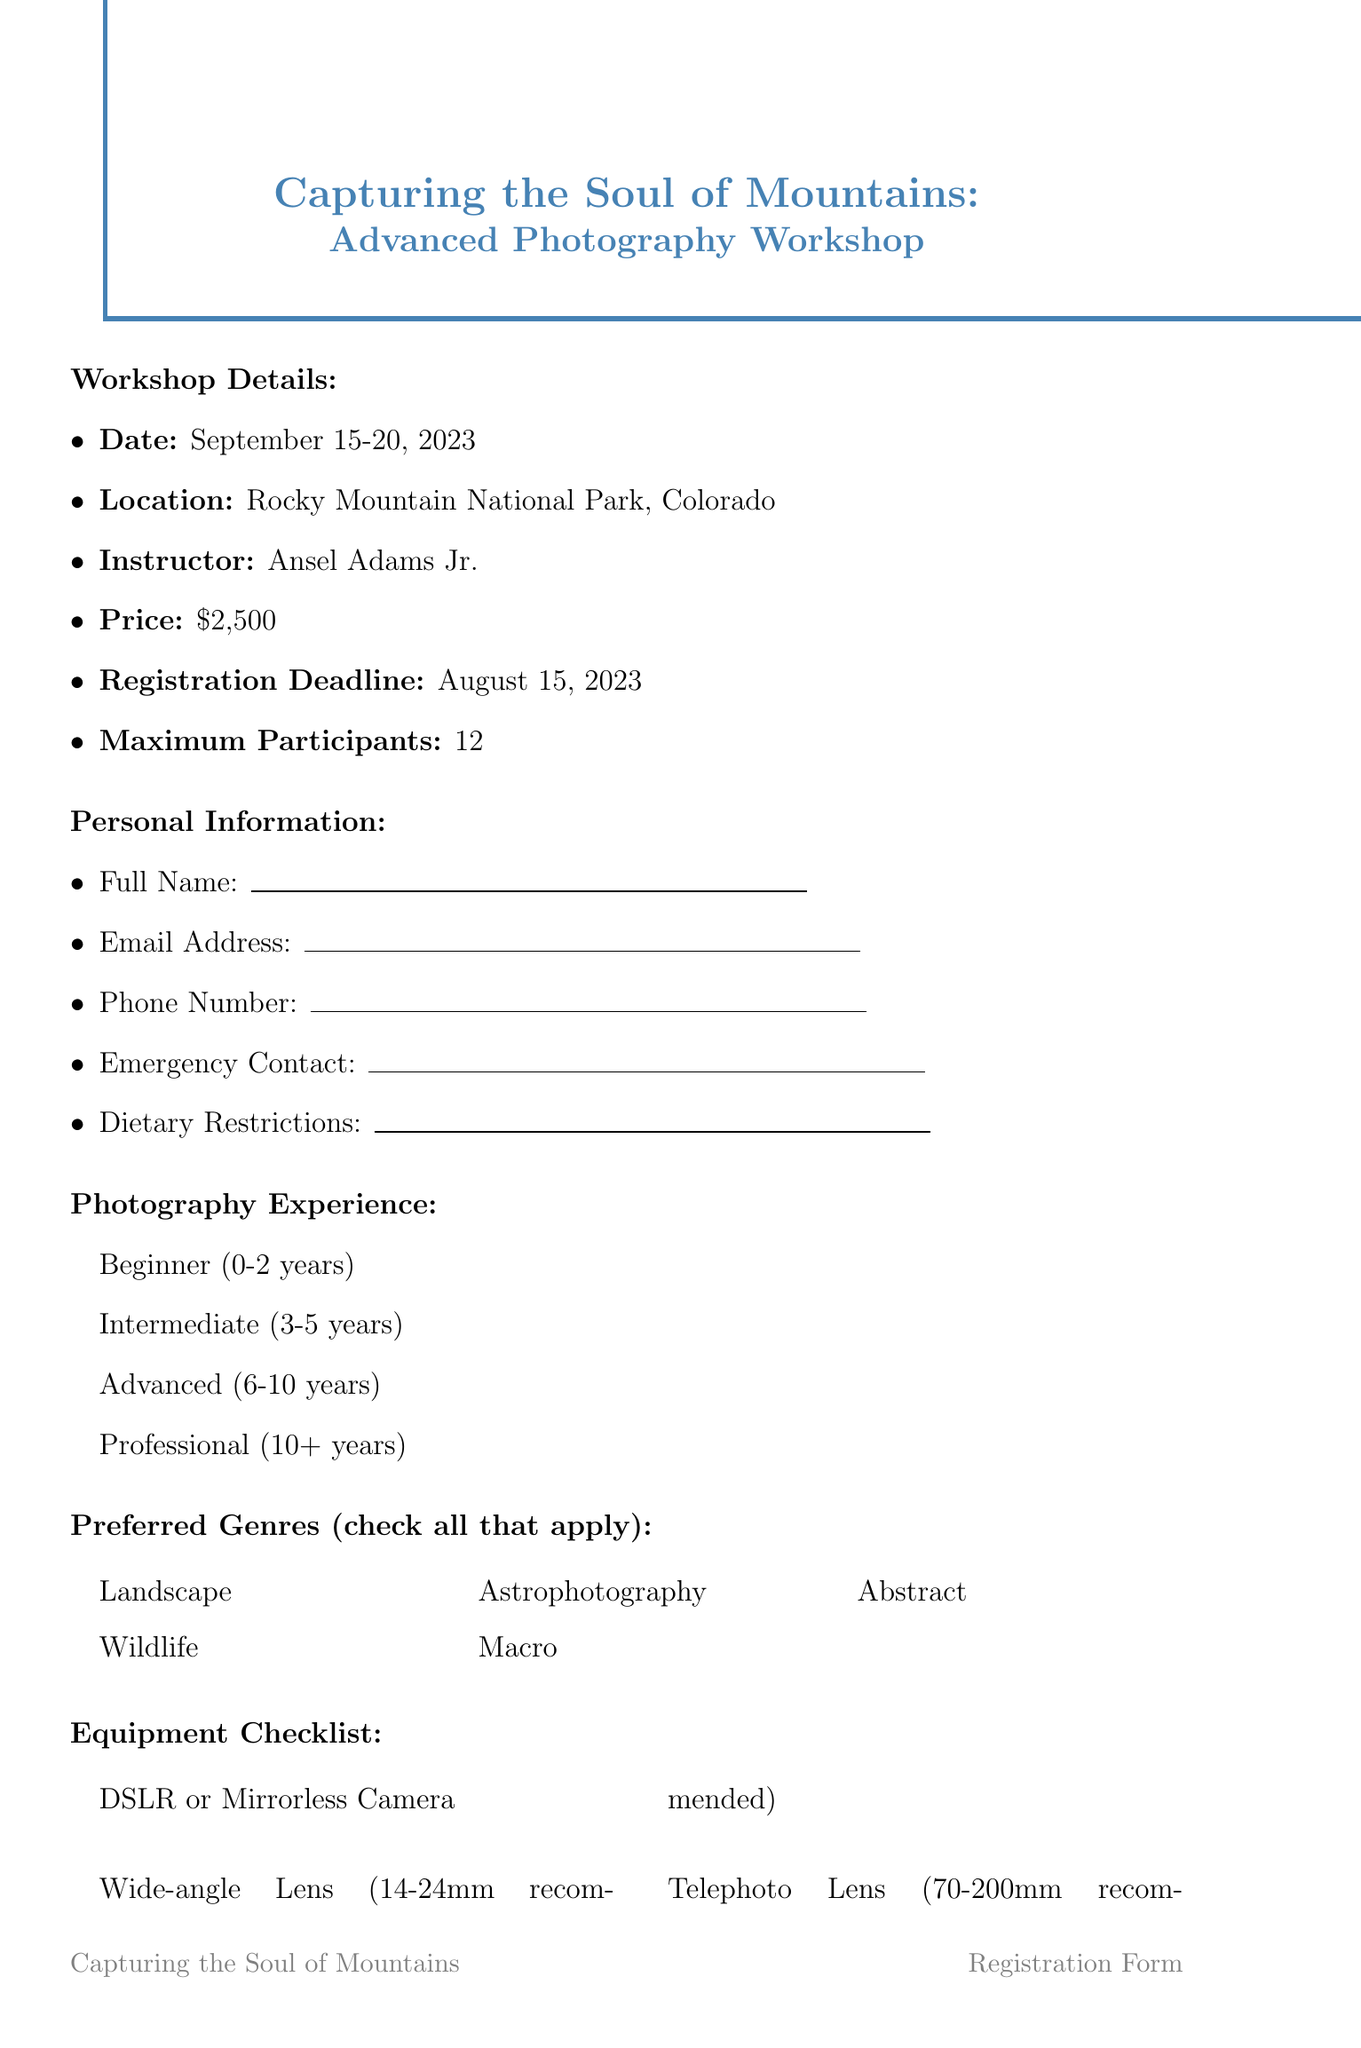What is the title of the workshop? The title of the workshop is mentioned at the top of the document.
Answer: Capturing the Soul of Mountains: Advanced Photography Workshop Who is the instructor of the workshop? The document provides the name of the instructor under workshop details.
Answer: Ansel Adams Jr What is the maximum number of participants allowed? The maximum participants is specified clearly in the workshop details section.
Answer: 12 What are the dates of the workshop? The dates of the workshop are stated in the workshop details section.
Answer: September 15-20, 2023 What is the price of the workshop? The price of attending the workshop is listed in the document.
Answer: $2500 What is the registration deadline? The registration deadline is given in the workshop details section.
Answer: August 15, 2023 What are the recommended lens types? The equipment checklist specifies which lens types are recommended for participants.
Answer: Wide-angle Lens (14-24mm recommended), Telephoto Lens (70-200mm recommended) What is the format for portfolio submission? The document explains the required format for submitting a portfolio.
Answer: Online gallery link or PDF What type of refund is offered if canceled more than 30 days before the workshop? The cancellation policy outlines the refund conditions clearly in the document.
Answer: Full Refund What are the goals of the workshop? The document lists the goals that participants can achieve by attending the workshop.
Answer: Improving composition techniques, Mastering exposure in challenging light conditions, Learning advanced post-processing techniques, Capturing the essence of mountain landscapes, Developing a unique artistic vision 